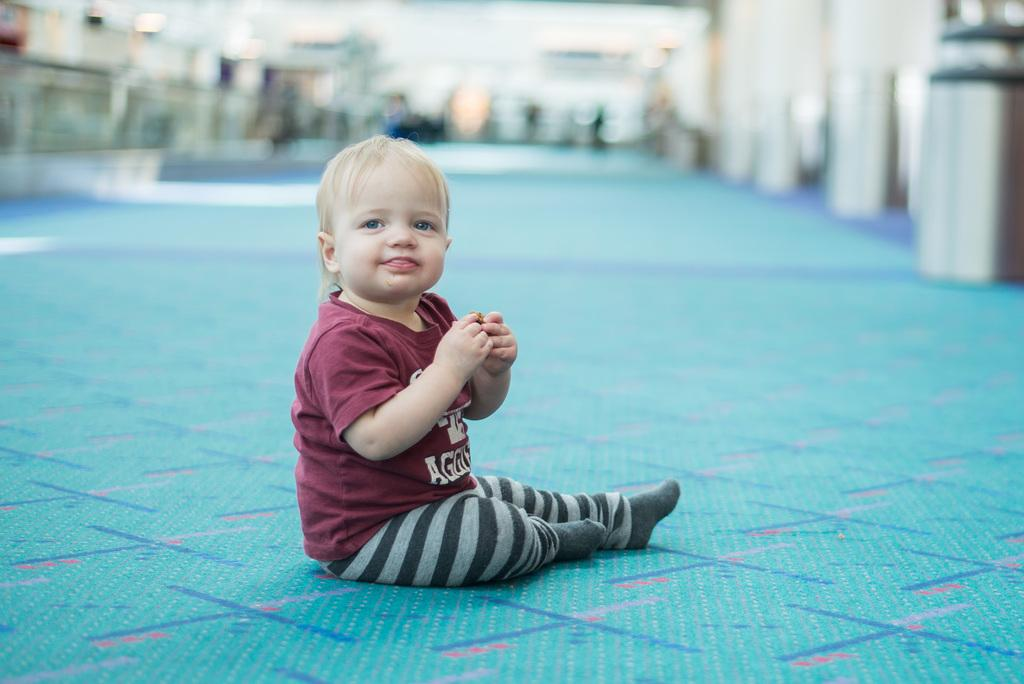Who is the main subject in the image? There is a little boy in the image. What is the boy doing in the image? The boy is sitting on the floor. Can you describe the background of the image? The background of the image is blurred. What is the boy's reaction to the fear in the image? There is no fear present in the image, so it is not possible to determine the boy's reaction to it. 